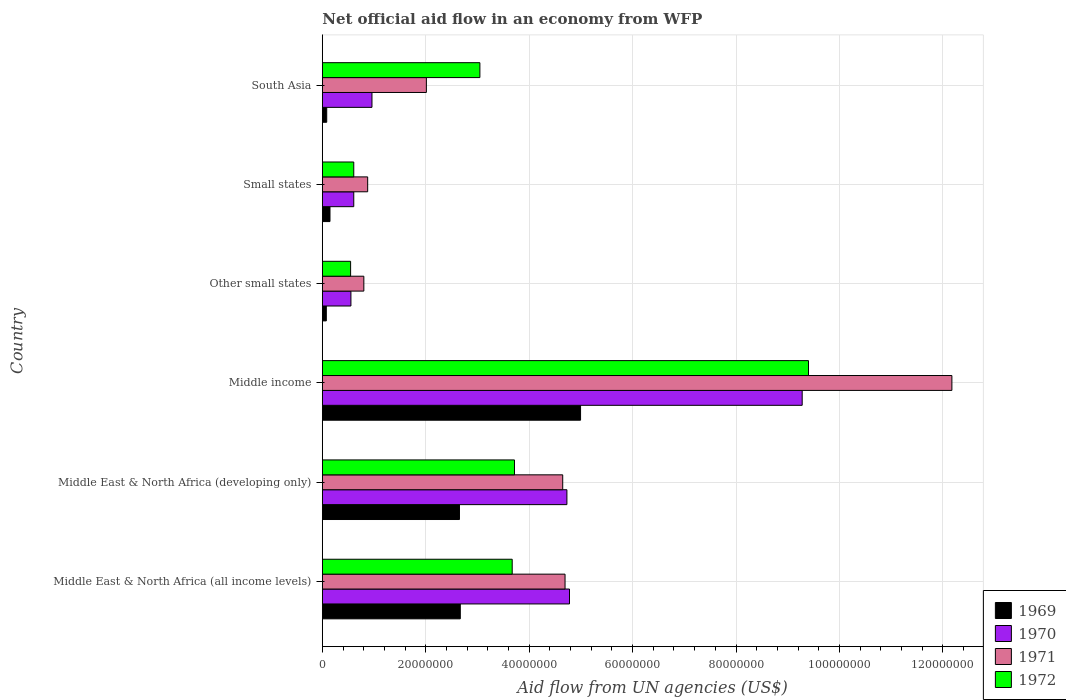How many different coloured bars are there?
Provide a short and direct response. 4. How many groups of bars are there?
Your response must be concise. 6. Are the number of bars per tick equal to the number of legend labels?
Offer a terse response. Yes. Are the number of bars on each tick of the Y-axis equal?
Offer a very short reply. Yes. How many bars are there on the 1st tick from the bottom?
Offer a very short reply. 4. What is the label of the 1st group of bars from the top?
Ensure brevity in your answer.  South Asia. In how many cases, is the number of bars for a given country not equal to the number of legend labels?
Your answer should be very brief. 0. What is the net official aid flow in 1969 in Other small states?
Your response must be concise. 7.70e+05. Across all countries, what is the maximum net official aid flow in 1969?
Make the answer very short. 4.99e+07. Across all countries, what is the minimum net official aid flow in 1971?
Your answer should be very brief. 8.03e+06. In which country was the net official aid flow in 1972 maximum?
Keep it short and to the point. Middle income. In which country was the net official aid flow in 1970 minimum?
Give a very brief answer. Other small states. What is the total net official aid flow in 1970 in the graph?
Provide a succinct answer. 2.09e+08. What is the difference between the net official aid flow in 1972 in Middle East & North Africa (all income levels) and that in Other small states?
Your answer should be compact. 3.12e+07. What is the difference between the net official aid flow in 1971 in Middle East & North Africa (all income levels) and the net official aid flow in 1969 in Small states?
Provide a succinct answer. 4.55e+07. What is the average net official aid flow in 1971 per country?
Provide a short and direct response. 4.20e+07. What is the difference between the net official aid flow in 1970 and net official aid flow in 1971 in Middle income?
Offer a terse response. -2.90e+07. What is the ratio of the net official aid flow in 1972 in Other small states to that in South Asia?
Provide a succinct answer. 0.18. Is the net official aid flow in 1969 in Middle East & North Africa (all income levels) less than that in Small states?
Give a very brief answer. No. What is the difference between the highest and the second highest net official aid flow in 1969?
Your answer should be very brief. 2.33e+07. What is the difference between the highest and the lowest net official aid flow in 1969?
Provide a succinct answer. 4.92e+07. In how many countries, is the net official aid flow in 1970 greater than the average net official aid flow in 1970 taken over all countries?
Provide a short and direct response. 3. What does the 1st bar from the bottom in Middle East & North Africa (all income levels) represents?
Provide a short and direct response. 1969. How many bars are there?
Make the answer very short. 24. Are all the bars in the graph horizontal?
Ensure brevity in your answer.  Yes. How many countries are there in the graph?
Offer a terse response. 6. What is the difference between two consecutive major ticks on the X-axis?
Offer a very short reply. 2.00e+07. Does the graph contain grids?
Make the answer very short. Yes. How are the legend labels stacked?
Your answer should be compact. Vertical. What is the title of the graph?
Provide a succinct answer. Net official aid flow in an economy from WFP. What is the label or title of the X-axis?
Provide a short and direct response. Aid flow from UN agencies (US$). What is the label or title of the Y-axis?
Offer a very short reply. Country. What is the Aid flow from UN agencies (US$) of 1969 in Middle East & North Africa (all income levels)?
Your answer should be very brief. 2.67e+07. What is the Aid flow from UN agencies (US$) of 1970 in Middle East & North Africa (all income levels)?
Ensure brevity in your answer.  4.78e+07. What is the Aid flow from UN agencies (US$) in 1971 in Middle East & North Africa (all income levels)?
Your answer should be compact. 4.69e+07. What is the Aid flow from UN agencies (US$) of 1972 in Middle East & North Africa (all income levels)?
Make the answer very short. 3.67e+07. What is the Aid flow from UN agencies (US$) of 1969 in Middle East & North Africa (developing only)?
Keep it short and to the point. 2.65e+07. What is the Aid flow from UN agencies (US$) in 1970 in Middle East & North Africa (developing only)?
Your response must be concise. 4.73e+07. What is the Aid flow from UN agencies (US$) of 1971 in Middle East & North Africa (developing only)?
Your answer should be compact. 4.65e+07. What is the Aid flow from UN agencies (US$) in 1972 in Middle East & North Africa (developing only)?
Make the answer very short. 3.72e+07. What is the Aid flow from UN agencies (US$) in 1969 in Middle income?
Keep it short and to the point. 4.99e+07. What is the Aid flow from UN agencies (US$) in 1970 in Middle income?
Your answer should be compact. 9.28e+07. What is the Aid flow from UN agencies (US$) in 1971 in Middle income?
Provide a short and direct response. 1.22e+08. What is the Aid flow from UN agencies (US$) of 1972 in Middle income?
Give a very brief answer. 9.40e+07. What is the Aid flow from UN agencies (US$) of 1969 in Other small states?
Keep it short and to the point. 7.70e+05. What is the Aid flow from UN agencies (US$) of 1970 in Other small states?
Provide a succinct answer. 5.53e+06. What is the Aid flow from UN agencies (US$) of 1971 in Other small states?
Ensure brevity in your answer.  8.03e+06. What is the Aid flow from UN agencies (US$) in 1972 in Other small states?
Provide a succinct answer. 5.47e+06. What is the Aid flow from UN agencies (US$) of 1969 in Small states?
Ensure brevity in your answer.  1.48e+06. What is the Aid flow from UN agencies (US$) in 1970 in Small states?
Provide a succinct answer. 6.08e+06. What is the Aid flow from UN agencies (US$) in 1971 in Small states?
Offer a terse response. 8.77e+06. What is the Aid flow from UN agencies (US$) of 1972 in Small states?
Your answer should be very brief. 6.08e+06. What is the Aid flow from UN agencies (US$) of 1969 in South Asia?
Ensure brevity in your answer.  8.50e+05. What is the Aid flow from UN agencies (US$) in 1970 in South Asia?
Give a very brief answer. 9.60e+06. What is the Aid flow from UN agencies (US$) of 1971 in South Asia?
Provide a short and direct response. 2.01e+07. What is the Aid flow from UN agencies (US$) in 1972 in South Asia?
Keep it short and to the point. 3.05e+07. Across all countries, what is the maximum Aid flow from UN agencies (US$) in 1969?
Provide a short and direct response. 4.99e+07. Across all countries, what is the maximum Aid flow from UN agencies (US$) in 1970?
Your answer should be very brief. 9.28e+07. Across all countries, what is the maximum Aid flow from UN agencies (US$) in 1971?
Your answer should be compact. 1.22e+08. Across all countries, what is the maximum Aid flow from UN agencies (US$) of 1972?
Provide a succinct answer. 9.40e+07. Across all countries, what is the minimum Aid flow from UN agencies (US$) in 1969?
Your answer should be compact. 7.70e+05. Across all countries, what is the minimum Aid flow from UN agencies (US$) in 1970?
Your response must be concise. 5.53e+06. Across all countries, what is the minimum Aid flow from UN agencies (US$) of 1971?
Offer a very short reply. 8.03e+06. Across all countries, what is the minimum Aid flow from UN agencies (US$) of 1972?
Your answer should be compact. 5.47e+06. What is the total Aid flow from UN agencies (US$) in 1969 in the graph?
Keep it short and to the point. 1.06e+08. What is the total Aid flow from UN agencies (US$) of 1970 in the graph?
Make the answer very short. 2.09e+08. What is the total Aid flow from UN agencies (US$) of 1971 in the graph?
Keep it short and to the point. 2.52e+08. What is the total Aid flow from UN agencies (US$) in 1972 in the graph?
Your answer should be compact. 2.10e+08. What is the difference between the Aid flow from UN agencies (US$) in 1969 in Middle East & North Africa (all income levels) and that in Middle East & North Africa (developing only)?
Ensure brevity in your answer.  1.60e+05. What is the difference between the Aid flow from UN agencies (US$) in 1972 in Middle East & North Africa (all income levels) and that in Middle East & North Africa (developing only)?
Make the answer very short. -4.40e+05. What is the difference between the Aid flow from UN agencies (US$) of 1969 in Middle East & North Africa (all income levels) and that in Middle income?
Your response must be concise. -2.33e+07. What is the difference between the Aid flow from UN agencies (US$) of 1970 in Middle East & North Africa (all income levels) and that in Middle income?
Provide a short and direct response. -4.50e+07. What is the difference between the Aid flow from UN agencies (US$) of 1971 in Middle East & North Africa (all income levels) and that in Middle income?
Give a very brief answer. -7.48e+07. What is the difference between the Aid flow from UN agencies (US$) of 1972 in Middle East & North Africa (all income levels) and that in Middle income?
Make the answer very short. -5.73e+07. What is the difference between the Aid flow from UN agencies (US$) of 1969 in Middle East & North Africa (all income levels) and that in Other small states?
Provide a succinct answer. 2.59e+07. What is the difference between the Aid flow from UN agencies (US$) of 1970 in Middle East & North Africa (all income levels) and that in Other small states?
Keep it short and to the point. 4.23e+07. What is the difference between the Aid flow from UN agencies (US$) in 1971 in Middle East & North Africa (all income levels) and that in Other small states?
Provide a succinct answer. 3.89e+07. What is the difference between the Aid flow from UN agencies (US$) of 1972 in Middle East & North Africa (all income levels) and that in Other small states?
Offer a very short reply. 3.12e+07. What is the difference between the Aid flow from UN agencies (US$) in 1969 in Middle East & North Africa (all income levels) and that in Small states?
Keep it short and to the point. 2.52e+07. What is the difference between the Aid flow from UN agencies (US$) in 1970 in Middle East & North Africa (all income levels) and that in Small states?
Make the answer very short. 4.17e+07. What is the difference between the Aid flow from UN agencies (US$) in 1971 in Middle East & North Africa (all income levels) and that in Small states?
Your response must be concise. 3.82e+07. What is the difference between the Aid flow from UN agencies (US$) of 1972 in Middle East & North Africa (all income levels) and that in Small states?
Your response must be concise. 3.06e+07. What is the difference between the Aid flow from UN agencies (US$) of 1969 in Middle East & North Africa (all income levels) and that in South Asia?
Give a very brief answer. 2.58e+07. What is the difference between the Aid flow from UN agencies (US$) in 1970 in Middle East & North Africa (all income levels) and that in South Asia?
Make the answer very short. 3.82e+07. What is the difference between the Aid flow from UN agencies (US$) of 1971 in Middle East & North Africa (all income levels) and that in South Asia?
Your answer should be very brief. 2.68e+07. What is the difference between the Aid flow from UN agencies (US$) of 1972 in Middle East & North Africa (all income levels) and that in South Asia?
Ensure brevity in your answer.  6.25e+06. What is the difference between the Aid flow from UN agencies (US$) of 1969 in Middle East & North Africa (developing only) and that in Middle income?
Your answer should be very brief. -2.34e+07. What is the difference between the Aid flow from UN agencies (US$) in 1970 in Middle East & North Africa (developing only) and that in Middle income?
Keep it short and to the point. -4.55e+07. What is the difference between the Aid flow from UN agencies (US$) of 1971 in Middle East & North Africa (developing only) and that in Middle income?
Provide a succinct answer. -7.53e+07. What is the difference between the Aid flow from UN agencies (US$) in 1972 in Middle East & North Africa (developing only) and that in Middle income?
Ensure brevity in your answer.  -5.69e+07. What is the difference between the Aid flow from UN agencies (US$) in 1969 in Middle East & North Africa (developing only) and that in Other small states?
Your answer should be compact. 2.58e+07. What is the difference between the Aid flow from UN agencies (US$) in 1970 in Middle East & North Africa (developing only) and that in Other small states?
Ensure brevity in your answer.  4.18e+07. What is the difference between the Aid flow from UN agencies (US$) of 1971 in Middle East & North Africa (developing only) and that in Other small states?
Your response must be concise. 3.85e+07. What is the difference between the Aid flow from UN agencies (US$) in 1972 in Middle East & North Africa (developing only) and that in Other small states?
Give a very brief answer. 3.17e+07. What is the difference between the Aid flow from UN agencies (US$) of 1969 in Middle East & North Africa (developing only) and that in Small states?
Keep it short and to the point. 2.50e+07. What is the difference between the Aid flow from UN agencies (US$) of 1970 in Middle East & North Africa (developing only) and that in Small states?
Provide a short and direct response. 4.12e+07. What is the difference between the Aid flow from UN agencies (US$) in 1971 in Middle East & North Africa (developing only) and that in Small states?
Give a very brief answer. 3.77e+07. What is the difference between the Aid flow from UN agencies (US$) of 1972 in Middle East & North Africa (developing only) and that in Small states?
Provide a succinct answer. 3.11e+07. What is the difference between the Aid flow from UN agencies (US$) in 1969 in Middle East & North Africa (developing only) and that in South Asia?
Your answer should be compact. 2.57e+07. What is the difference between the Aid flow from UN agencies (US$) in 1970 in Middle East & North Africa (developing only) and that in South Asia?
Provide a succinct answer. 3.77e+07. What is the difference between the Aid flow from UN agencies (US$) of 1971 in Middle East & North Africa (developing only) and that in South Asia?
Provide a succinct answer. 2.64e+07. What is the difference between the Aid flow from UN agencies (US$) of 1972 in Middle East & North Africa (developing only) and that in South Asia?
Your response must be concise. 6.69e+06. What is the difference between the Aid flow from UN agencies (US$) of 1969 in Middle income and that in Other small states?
Your response must be concise. 4.92e+07. What is the difference between the Aid flow from UN agencies (US$) of 1970 in Middle income and that in Other small states?
Ensure brevity in your answer.  8.73e+07. What is the difference between the Aid flow from UN agencies (US$) in 1971 in Middle income and that in Other small states?
Provide a succinct answer. 1.14e+08. What is the difference between the Aid flow from UN agencies (US$) in 1972 in Middle income and that in Other small states?
Your answer should be very brief. 8.86e+07. What is the difference between the Aid flow from UN agencies (US$) of 1969 in Middle income and that in Small states?
Your answer should be compact. 4.85e+07. What is the difference between the Aid flow from UN agencies (US$) of 1970 in Middle income and that in Small states?
Offer a very short reply. 8.67e+07. What is the difference between the Aid flow from UN agencies (US$) in 1971 in Middle income and that in Small states?
Make the answer very short. 1.13e+08. What is the difference between the Aid flow from UN agencies (US$) of 1972 in Middle income and that in Small states?
Offer a very short reply. 8.79e+07. What is the difference between the Aid flow from UN agencies (US$) of 1969 in Middle income and that in South Asia?
Offer a very short reply. 4.91e+07. What is the difference between the Aid flow from UN agencies (US$) of 1970 in Middle income and that in South Asia?
Ensure brevity in your answer.  8.32e+07. What is the difference between the Aid flow from UN agencies (US$) in 1971 in Middle income and that in South Asia?
Keep it short and to the point. 1.02e+08. What is the difference between the Aid flow from UN agencies (US$) in 1972 in Middle income and that in South Asia?
Give a very brief answer. 6.36e+07. What is the difference between the Aid flow from UN agencies (US$) in 1969 in Other small states and that in Small states?
Ensure brevity in your answer.  -7.10e+05. What is the difference between the Aid flow from UN agencies (US$) in 1970 in Other small states and that in Small states?
Your answer should be very brief. -5.50e+05. What is the difference between the Aid flow from UN agencies (US$) of 1971 in Other small states and that in Small states?
Keep it short and to the point. -7.40e+05. What is the difference between the Aid flow from UN agencies (US$) in 1972 in Other small states and that in Small states?
Offer a very short reply. -6.10e+05. What is the difference between the Aid flow from UN agencies (US$) of 1969 in Other small states and that in South Asia?
Offer a very short reply. -8.00e+04. What is the difference between the Aid flow from UN agencies (US$) of 1970 in Other small states and that in South Asia?
Provide a short and direct response. -4.07e+06. What is the difference between the Aid flow from UN agencies (US$) of 1971 in Other small states and that in South Asia?
Make the answer very short. -1.21e+07. What is the difference between the Aid flow from UN agencies (US$) in 1972 in Other small states and that in South Asia?
Provide a succinct answer. -2.50e+07. What is the difference between the Aid flow from UN agencies (US$) of 1969 in Small states and that in South Asia?
Offer a terse response. 6.30e+05. What is the difference between the Aid flow from UN agencies (US$) in 1970 in Small states and that in South Asia?
Provide a short and direct response. -3.52e+06. What is the difference between the Aid flow from UN agencies (US$) in 1971 in Small states and that in South Asia?
Offer a very short reply. -1.14e+07. What is the difference between the Aid flow from UN agencies (US$) of 1972 in Small states and that in South Asia?
Ensure brevity in your answer.  -2.44e+07. What is the difference between the Aid flow from UN agencies (US$) of 1969 in Middle East & North Africa (all income levels) and the Aid flow from UN agencies (US$) of 1970 in Middle East & North Africa (developing only)?
Offer a terse response. -2.06e+07. What is the difference between the Aid flow from UN agencies (US$) in 1969 in Middle East & North Africa (all income levels) and the Aid flow from UN agencies (US$) in 1971 in Middle East & North Africa (developing only)?
Ensure brevity in your answer.  -1.98e+07. What is the difference between the Aid flow from UN agencies (US$) in 1969 in Middle East & North Africa (all income levels) and the Aid flow from UN agencies (US$) in 1972 in Middle East & North Africa (developing only)?
Keep it short and to the point. -1.05e+07. What is the difference between the Aid flow from UN agencies (US$) in 1970 in Middle East & North Africa (all income levels) and the Aid flow from UN agencies (US$) in 1971 in Middle East & North Africa (developing only)?
Keep it short and to the point. 1.31e+06. What is the difference between the Aid flow from UN agencies (US$) of 1970 in Middle East & North Africa (all income levels) and the Aid flow from UN agencies (US$) of 1972 in Middle East & North Africa (developing only)?
Provide a succinct answer. 1.06e+07. What is the difference between the Aid flow from UN agencies (US$) of 1971 in Middle East & North Africa (all income levels) and the Aid flow from UN agencies (US$) of 1972 in Middle East & North Africa (developing only)?
Make the answer very short. 9.78e+06. What is the difference between the Aid flow from UN agencies (US$) in 1969 in Middle East & North Africa (all income levels) and the Aid flow from UN agencies (US$) in 1970 in Middle income?
Your answer should be very brief. -6.61e+07. What is the difference between the Aid flow from UN agencies (US$) in 1969 in Middle East & North Africa (all income levels) and the Aid flow from UN agencies (US$) in 1971 in Middle income?
Offer a very short reply. -9.51e+07. What is the difference between the Aid flow from UN agencies (US$) of 1969 in Middle East & North Africa (all income levels) and the Aid flow from UN agencies (US$) of 1972 in Middle income?
Provide a succinct answer. -6.73e+07. What is the difference between the Aid flow from UN agencies (US$) of 1970 in Middle East & North Africa (all income levels) and the Aid flow from UN agencies (US$) of 1971 in Middle income?
Your response must be concise. -7.40e+07. What is the difference between the Aid flow from UN agencies (US$) of 1970 in Middle East & North Africa (all income levels) and the Aid flow from UN agencies (US$) of 1972 in Middle income?
Provide a succinct answer. -4.62e+07. What is the difference between the Aid flow from UN agencies (US$) of 1971 in Middle East & North Africa (all income levels) and the Aid flow from UN agencies (US$) of 1972 in Middle income?
Make the answer very short. -4.71e+07. What is the difference between the Aid flow from UN agencies (US$) in 1969 in Middle East & North Africa (all income levels) and the Aid flow from UN agencies (US$) in 1970 in Other small states?
Your answer should be compact. 2.12e+07. What is the difference between the Aid flow from UN agencies (US$) of 1969 in Middle East & North Africa (all income levels) and the Aid flow from UN agencies (US$) of 1971 in Other small states?
Provide a succinct answer. 1.86e+07. What is the difference between the Aid flow from UN agencies (US$) in 1969 in Middle East & North Africa (all income levels) and the Aid flow from UN agencies (US$) in 1972 in Other small states?
Give a very brief answer. 2.12e+07. What is the difference between the Aid flow from UN agencies (US$) in 1970 in Middle East & North Africa (all income levels) and the Aid flow from UN agencies (US$) in 1971 in Other small states?
Provide a short and direct response. 3.98e+07. What is the difference between the Aid flow from UN agencies (US$) in 1970 in Middle East & North Africa (all income levels) and the Aid flow from UN agencies (US$) in 1972 in Other small states?
Offer a very short reply. 4.23e+07. What is the difference between the Aid flow from UN agencies (US$) in 1971 in Middle East & North Africa (all income levels) and the Aid flow from UN agencies (US$) in 1972 in Other small states?
Offer a very short reply. 4.15e+07. What is the difference between the Aid flow from UN agencies (US$) of 1969 in Middle East & North Africa (all income levels) and the Aid flow from UN agencies (US$) of 1970 in Small states?
Keep it short and to the point. 2.06e+07. What is the difference between the Aid flow from UN agencies (US$) in 1969 in Middle East & North Africa (all income levels) and the Aid flow from UN agencies (US$) in 1971 in Small states?
Your answer should be very brief. 1.79e+07. What is the difference between the Aid flow from UN agencies (US$) of 1969 in Middle East & North Africa (all income levels) and the Aid flow from UN agencies (US$) of 1972 in Small states?
Your answer should be very brief. 2.06e+07. What is the difference between the Aid flow from UN agencies (US$) of 1970 in Middle East & North Africa (all income levels) and the Aid flow from UN agencies (US$) of 1971 in Small states?
Provide a succinct answer. 3.90e+07. What is the difference between the Aid flow from UN agencies (US$) in 1970 in Middle East & North Africa (all income levels) and the Aid flow from UN agencies (US$) in 1972 in Small states?
Keep it short and to the point. 4.17e+07. What is the difference between the Aid flow from UN agencies (US$) of 1971 in Middle East & North Africa (all income levels) and the Aid flow from UN agencies (US$) of 1972 in Small states?
Make the answer very short. 4.09e+07. What is the difference between the Aid flow from UN agencies (US$) of 1969 in Middle East & North Africa (all income levels) and the Aid flow from UN agencies (US$) of 1970 in South Asia?
Offer a terse response. 1.71e+07. What is the difference between the Aid flow from UN agencies (US$) in 1969 in Middle East & North Africa (all income levels) and the Aid flow from UN agencies (US$) in 1971 in South Asia?
Your answer should be very brief. 6.56e+06. What is the difference between the Aid flow from UN agencies (US$) in 1969 in Middle East & North Africa (all income levels) and the Aid flow from UN agencies (US$) in 1972 in South Asia?
Give a very brief answer. -3.79e+06. What is the difference between the Aid flow from UN agencies (US$) of 1970 in Middle East & North Africa (all income levels) and the Aid flow from UN agencies (US$) of 1971 in South Asia?
Your response must be concise. 2.77e+07. What is the difference between the Aid flow from UN agencies (US$) in 1970 in Middle East & North Africa (all income levels) and the Aid flow from UN agencies (US$) in 1972 in South Asia?
Give a very brief answer. 1.73e+07. What is the difference between the Aid flow from UN agencies (US$) of 1971 in Middle East & North Africa (all income levels) and the Aid flow from UN agencies (US$) of 1972 in South Asia?
Provide a succinct answer. 1.65e+07. What is the difference between the Aid flow from UN agencies (US$) in 1969 in Middle East & North Africa (developing only) and the Aid flow from UN agencies (US$) in 1970 in Middle income?
Provide a short and direct response. -6.63e+07. What is the difference between the Aid flow from UN agencies (US$) of 1969 in Middle East & North Africa (developing only) and the Aid flow from UN agencies (US$) of 1971 in Middle income?
Provide a succinct answer. -9.52e+07. What is the difference between the Aid flow from UN agencies (US$) of 1969 in Middle East & North Africa (developing only) and the Aid flow from UN agencies (US$) of 1972 in Middle income?
Offer a very short reply. -6.75e+07. What is the difference between the Aid flow from UN agencies (US$) of 1970 in Middle East & North Africa (developing only) and the Aid flow from UN agencies (US$) of 1971 in Middle income?
Keep it short and to the point. -7.44e+07. What is the difference between the Aid flow from UN agencies (US$) of 1970 in Middle East & North Africa (developing only) and the Aid flow from UN agencies (US$) of 1972 in Middle income?
Your answer should be compact. -4.67e+07. What is the difference between the Aid flow from UN agencies (US$) in 1971 in Middle East & North Africa (developing only) and the Aid flow from UN agencies (US$) in 1972 in Middle income?
Your answer should be very brief. -4.75e+07. What is the difference between the Aid flow from UN agencies (US$) of 1969 in Middle East & North Africa (developing only) and the Aid flow from UN agencies (US$) of 1970 in Other small states?
Give a very brief answer. 2.10e+07. What is the difference between the Aid flow from UN agencies (US$) in 1969 in Middle East & North Africa (developing only) and the Aid flow from UN agencies (US$) in 1971 in Other small states?
Your response must be concise. 1.85e+07. What is the difference between the Aid flow from UN agencies (US$) of 1969 in Middle East & North Africa (developing only) and the Aid flow from UN agencies (US$) of 1972 in Other small states?
Your answer should be compact. 2.10e+07. What is the difference between the Aid flow from UN agencies (US$) of 1970 in Middle East & North Africa (developing only) and the Aid flow from UN agencies (US$) of 1971 in Other small states?
Ensure brevity in your answer.  3.93e+07. What is the difference between the Aid flow from UN agencies (US$) in 1970 in Middle East & North Africa (developing only) and the Aid flow from UN agencies (US$) in 1972 in Other small states?
Provide a short and direct response. 4.18e+07. What is the difference between the Aid flow from UN agencies (US$) of 1971 in Middle East & North Africa (developing only) and the Aid flow from UN agencies (US$) of 1972 in Other small states?
Make the answer very short. 4.10e+07. What is the difference between the Aid flow from UN agencies (US$) of 1969 in Middle East & North Africa (developing only) and the Aid flow from UN agencies (US$) of 1970 in Small states?
Provide a succinct answer. 2.04e+07. What is the difference between the Aid flow from UN agencies (US$) of 1969 in Middle East & North Africa (developing only) and the Aid flow from UN agencies (US$) of 1971 in Small states?
Your response must be concise. 1.78e+07. What is the difference between the Aid flow from UN agencies (US$) in 1969 in Middle East & North Africa (developing only) and the Aid flow from UN agencies (US$) in 1972 in Small states?
Ensure brevity in your answer.  2.04e+07. What is the difference between the Aid flow from UN agencies (US$) of 1970 in Middle East & North Africa (developing only) and the Aid flow from UN agencies (US$) of 1971 in Small states?
Keep it short and to the point. 3.85e+07. What is the difference between the Aid flow from UN agencies (US$) in 1970 in Middle East & North Africa (developing only) and the Aid flow from UN agencies (US$) in 1972 in Small states?
Make the answer very short. 4.12e+07. What is the difference between the Aid flow from UN agencies (US$) of 1971 in Middle East & North Africa (developing only) and the Aid flow from UN agencies (US$) of 1972 in Small states?
Offer a terse response. 4.04e+07. What is the difference between the Aid flow from UN agencies (US$) in 1969 in Middle East & North Africa (developing only) and the Aid flow from UN agencies (US$) in 1970 in South Asia?
Provide a succinct answer. 1.69e+07. What is the difference between the Aid flow from UN agencies (US$) in 1969 in Middle East & North Africa (developing only) and the Aid flow from UN agencies (US$) in 1971 in South Asia?
Ensure brevity in your answer.  6.40e+06. What is the difference between the Aid flow from UN agencies (US$) of 1969 in Middle East & North Africa (developing only) and the Aid flow from UN agencies (US$) of 1972 in South Asia?
Make the answer very short. -3.95e+06. What is the difference between the Aid flow from UN agencies (US$) of 1970 in Middle East & North Africa (developing only) and the Aid flow from UN agencies (US$) of 1971 in South Asia?
Make the answer very short. 2.72e+07. What is the difference between the Aid flow from UN agencies (US$) of 1970 in Middle East & North Africa (developing only) and the Aid flow from UN agencies (US$) of 1972 in South Asia?
Give a very brief answer. 1.68e+07. What is the difference between the Aid flow from UN agencies (US$) of 1971 in Middle East & North Africa (developing only) and the Aid flow from UN agencies (US$) of 1972 in South Asia?
Your response must be concise. 1.60e+07. What is the difference between the Aid flow from UN agencies (US$) in 1969 in Middle income and the Aid flow from UN agencies (US$) in 1970 in Other small states?
Offer a very short reply. 4.44e+07. What is the difference between the Aid flow from UN agencies (US$) of 1969 in Middle income and the Aid flow from UN agencies (US$) of 1971 in Other small states?
Provide a short and direct response. 4.19e+07. What is the difference between the Aid flow from UN agencies (US$) of 1969 in Middle income and the Aid flow from UN agencies (US$) of 1972 in Other small states?
Provide a succinct answer. 4.45e+07. What is the difference between the Aid flow from UN agencies (US$) of 1970 in Middle income and the Aid flow from UN agencies (US$) of 1971 in Other small states?
Your answer should be compact. 8.48e+07. What is the difference between the Aid flow from UN agencies (US$) of 1970 in Middle income and the Aid flow from UN agencies (US$) of 1972 in Other small states?
Keep it short and to the point. 8.73e+07. What is the difference between the Aid flow from UN agencies (US$) of 1971 in Middle income and the Aid flow from UN agencies (US$) of 1972 in Other small states?
Provide a short and direct response. 1.16e+08. What is the difference between the Aid flow from UN agencies (US$) in 1969 in Middle income and the Aid flow from UN agencies (US$) in 1970 in Small states?
Your response must be concise. 4.39e+07. What is the difference between the Aid flow from UN agencies (US$) in 1969 in Middle income and the Aid flow from UN agencies (US$) in 1971 in Small states?
Give a very brief answer. 4.12e+07. What is the difference between the Aid flow from UN agencies (US$) of 1969 in Middle income and the Aid flow from UN agencies (US$) of 1972 in Small states?
Provide a succinct answer. 4.39e+07. What is the difference between the Aid flow from UN agencies (US$) of 1970 in Middle income and the Aid flow from UN agencies (US$) of 1971 in Small states?
Give a very brief answer. 8.40e+07. What is the difference between the Aid flow from UN agencies (US$) in 1970 in Middle income and the Aid flow from UN agencies (US$) in 1972 in Small states?
Provide a succinct answer. 8.67e+07. What is the difference between the Aid flow from UN agencies (US$) of 1971 in Middle income and the Aid flow from UN agencies (US$) of 1972 in Small states?
Your response must be concise. 1.16e+08. What is the difference between the Aid flow from UN agencies (US$) of 1969 in Middle income and the Aid flow from UN agencies (US$) of 1970 in South Asia?
Ensure brevity in your answer.  4.03e+07. What is the difference between the Aid flow from UN agencies (US$) in 1969 in Middle income and the Aid flow from UN agencies (US$) in 1971 in South Asia?
Your answer should be compact. 2.98e+07. What is the difference between the Aid flow from UN agencies (US$) of 1969 in Middle income and the Aid flow from UN agencies (US$) of 1972 in South Asia?
Offer a terse response. 1.95e+07. What is the difference between the Aid flow from UN agencies (US$) of 1970 in Middle income and the Aid flow from UN agencies (US$) of 1971 in South Asia?
Your answer should be very brief. 7.27e+07. What is the difference between the Aid flow from UN agencies (US$) in 1970 in Middle income and the Aid flow from UN agencies (US$) in 1972 in South Asia?
Ensure brevity in your answer.  6.23e+07. What is the difference between the Aid flow from UN agencies (US$) of 1971 in Middle income and the Aid flow from UN agencies (US$) of 1972 in South Asia?
Your answer should be compact. 9.13e+07. What is the difference between the Aid flow from UN agencies (US$) of 1969 in Other small states and the Aid flow from UN agencies (US$) of 1970 in Small states?
Give a very brief answer. -5.31e+06. What is the difference between the Aid flow from UN agencies (US$) of 1969 in Other small states and the Aid flow from UN agencies (US$) of 1971 in Small states?
Offer a terse response. -8.00e+06. What is the difference between the Aid flow from UN agencies (US$) in 1969 in Other small states and the Aid flow from UN agencies (US$) in 1972 in Small states?
Your response must be concise. -5.31e+06. What is the difference between the Aid flow from UN agencies (US$) in 1970 in Other small states and the Aid flow from UN agencies (US$) in 1971 in Small states?
Keep it short and to the point. -3.24e+06. What is the difference between the Aid flow from UN agencies (US$) of 1970 in Other small states and the Aid flow from UN agencies (US$) of 1972 in Small states?
Give a very brief answer. -5.50e+05. What is the difference between the Aid flow from UN agencies (US$) in 1971 in Other small states and the Aid flow from UN agencies (US$) in 1972 in Small states?
Your answer should be compact. 1.95e+06. What is the difference between the Aid flow from UN agencies (US$) in 1969 in Other small states and the Aid flow from UN agencies (US$) in 1970 in South Asia?
Your response must be concise. -8.83e+06. What is the difference between the Aid flow from UN agencies (US$) of 1969 in Other small states and the Aid flow from UN agencies (US$) of 1971 in South Asia?
Ensure brevity in your answer.  -1.94e+07. What is the difference between the Aid flow from UN agencies (US$) in 1969 in Other small states and the Aid flow from UN agencies (US$) in 1972 in South Asia?
Your answer should be very brief. -2.97e+07. What is the difference between the Aid flow from UN agencies (US$) in 1970 in Other small states and the Aid flow from UN agencies (US$) in 1971 in South Asia?
Your answer should be compact. -1.46e+07. What is the difference between the Aid flow from UN agencies (US$) in 1970 in Other small states and the Aid flow from UN agencies (US$) in 1972 in South Asia?
Your answer should be very brief. -2.49e+07. What is the difference between the Aid flow from UN agencies (US$) in 1971 in Other small states and the Aid flow from UN agencies (US$) in 1972 in South Asia?
Your answer should be very brief. -2.24e+07. What is the difference between the Aid flow from UN agencies (US$) of 1969 in Small states and the Aid flow from UN agencies (US$) of 1970 in South Asia?
Provide a succinct answer. -8.12e+06. What is the difference between the Aid flow from UN agencies (US$) of 1969 in Small states and the Aid flow from UN agencies (US$) of 1971 in South Asia?
Your answer should be very brief. -1.86e+07. What is the difference between the Aid flow from UN agencies (US$) in 1969 in Small states and the Aid flow from UN agencies (US$) in 1972 in South Asia?
Your response must be concise. -2.90e+07. What is the difference between the Aid flow from UN agencies (US$) in 1970 in Small states and the Aid flow from UN agencies (US$) in 1971 in South Asia?
Make the answer very short. -1.40e+07. What is the difference between the Aid flow from UN agencies (US$) in 1970 in Small states and the Aid flow from UN agencies (US$) in 1972 in South Asia?
Your response must be concise. -2.44e+07. What is the difference between the Aid flow from UN agencies (US$) of 1971 in Small states and the Aid flow from UN agencies (US$) of 1972 in South Asia?
Offer a very short reply. -2.17e+07. What is the average Aid flow from UN agencies (US$) of 1969 per country?
Provide a succinct answer. 1.77e+07. What is the average Aid flow from UN agencies (US$) in 1970 per country?
Your answer should be compact. 3.49e+07. What is the average Aid flow from UN agencies (US$) in 1971 per country?
Provide a short and direct response. 4.20e+07. What is the average Aid flow from UN agencies (US$) of 1972 per country?
Make the answer very short. 3.50e+07. What is the difference between the Aid flow from UN agencies (US$) in 1969 and Aid flow from UN agencies (US$) in 1970 in Middle East & North Africa (all income levels)?
Provide a succinct answer. -2.11e+07. What is the difference between the Aid flow from UN agencies (US$) in 1969 and Aid flow from UN agencies (US$) in 1971 in Middle East & North Africa (all income levels)?
Keep it short and to the point. -2.03e+07. What is the difference between the Aid flow from UN agencies (US$) of 1969 and Aid flow from UN agencies (US$) of 1972 in Middle East & North Africa (all income levels)?
Provide a short and direct response. -1.00e+07. What is the difference between the Aid flow from UN agencies (US$) in 1970 and Aid flow from UN agencies (US$) in 1971 in Middle East & North Africa (all income levels)?
Offer a very short reply. 8.60e+05. What is the difference between the Aid flow from UN agencies (US$) in 1970 and Aid flow from UN agencies (US$) in 1972 in Middle East & North Africa (all income levels)?
Your answer should be very brief. 1.11e+07. What is the difference between the Aid flow from UN agencies (US$) in 1971 and Aid flow from UN agencies (US$) in 1972 in Middle East & North Africa (all income levels)?
Offer a terse response. 1.02e+07. What is the difference between the Aid flow from UN agencies (US$) in 1969 and Aid flow from UN agencies (US$) in 1970 in Middle East & North Africa (developing only)?
Your response must be concise. -2.08e+07. What is the difference between the Aid flow from UN agencies (US$) of 1969 and Aid flow from UN agencies (US$) of 1971 in Middle East & North Africa (developing only)?
Your response must be concise. -2.00e+07. What is the difference between the Aid flow from UN agencies (US$) in 1969 and Aid flow from UN agencies (US$) in 1972 in Middle East & North Africa (developing only)?
Make the answer very short. -1.06e+07. What is the difference between the Aid flow from UN agencies (US$) of 1970 and Aid flow from UN agencies (US$) of 1971 in Middle East & North Africa (developing only)?
Keep it short and to the point. 8.10e+05. What is the difference between the Aid flow from UN agencies (US$) of 1970 and Aid flow from UN agencies (US$) of 1972 in Middle East & North Africa (developing only)?
Offer a terse response. 1.01e+07. What is the difference between the Aid flow from UN agencies (US$) of 1971 and Aid flow from UN agencies (US$) of 1972 in Middle East & North Africa (developing only)?
Make the answer very short. 9.33e+06. What is the difference between the Aid flow from UN agencies (US$) of 1969 and Aid flow from UN agencies (US$) of 1970 in Middle income?
Offer a very short reply. -4.29e+07. What is the difference between the Aid flow from UN agencies (US$) in 1969 and Aid flow from UN agencies (US$) in 1971 in Middle income?
Your answer should be compact. -7.18e+07. What is the difference between the Aid flow from UN agencies (US$) in 1969 and Aid flow from UN agencies (US$) in 1972 in Middle income?
Your response must be concise. -4.41e+07. What is the difference between the Aid flow from UN agencies (US$) of 1970 and Aid flow from UN agencies (US$) of 1971 in Middle income?
Keep it short and to the point. -2.90e+07. What is the difference between the Aid flow from UN agencies (US$) of 1970 and Aid flow from UN agencies (US$) of 1972 in Middle income?
Make the answer very short. -1.22e+06. What is the difference between the Aid flow from UN agencies (US$) in 1971 and Aid flow from UN agencies (US$) in 1972 in Middle income?
Ensure brevity in your answer.  2.77e+07. What is the difference between the Aid flow from UN agencies (US$) of 1969 and Aid flow from UN agencies (US$) of 1970 in Other small states?
Ensure brevity in your answer.  -4.76e+06. What is the difference between the Aid flow from UN agencies (US$) in 1969 and Aid flow from UN agencies (US$) in 1971 in Other small states?
Make the answer very short. -7.26e+06. What is the difference between the Aid flow from UN agencies (US$) of 1969 and Aid flow from UN agencies (US$) of 1972 in Other small states?
Your answer should be compact. -4.70e+06. What is the difference between the Aid flow from UN agencies (US$) of 1970 and Aid flow from UN agencies (US$) of 1971 in Other small states?
Your answer should be compact. -2.50e+06. What is the difference between the Aid flow from UN agencies (US$) of 1971 and Aid flow from UN agencies (US$) of 1972 in Other small states?
Make the answer very short. 2.56e+06. What is the difference between the Aid flow from UN agencies (US$) of 1969 and Aid flow from UN agencies (US$) of 1970 in Small states?
Keep it short and to the point. -4.60e+06. What is the difference between the Aid flow from UN agencies (US$) of 1969 and Aid flow from UN agencies (US$) of 1971 in Small states?
Keep it short and to the point. -7.29e+06. What is the difference between the Aid flow from UN agencies (US$) in 1969 and Aid flow from UN agencies (US$) in 1972 in Small states?
Your response must be concise. -4.60e+06. What is the difference between the Aid flow from UN agencies (US$) in 1970 and Aid flow from UN agencies (US$) in 1971 in Small states?
Offer a terse response. -2.69e+06. What is the difference between the Aid flow from UN agencies (US$) of 1971 and Aid flow from UN agencies (US$) of 1972 in Small states?
Keep it short and to the point. 2.69e+06. What is the difference between the Aid flow from UN agencies (US$) of 1969 and Aid flow from UN agencies (US$) of 1970 in South Asia?
Provide a succinct answer. -8.75e+06. What is the difference between the Aid flow from UN agencies (US$) of 1969 and Aid flow from UN agencies (US$) of 1971 in South Asia?
Offer a terse response. -1.93e+07. What is the difference between the Aid flow from UN agencies (US$) in 1969 and Aid flow from UN agencies (US$) in 1972 in South Asia?
Give a very brief answer. -2.96e+07. What is the difference between the Aid flow from UN agencies (US$) of 1970 and Aid flow from UN agencies (US$) of 1971 in South Asia?
Give a very brief answer. -1.05e+07. What is the difference between the Aid flow from UN agencies (US$) in 1970 and Aid flow from UN agencies (US$) in 1972 in South Asia?
Give a very brief answer. -2.09e+07. What is the difference between the Aid flow from UN agencies (US$) in 1971 and Aid flow from UN agencies (US$) in 1972 in South Asia?
Offer a terse response. -1.04e+07. What is the ratio of the Aid flow from UN agencies (US$) of 1969 in Middle East & North Africa (all income levels) to that in Middle East & North Africa (developing only)?
Provide a succinct answer. 1.01. What is the ratio of the Aid flow from UN agencies (US$) of 1970 in Middle East & North Africa (all income levels) to that in Middle East & North Africa (developing only)?
Make the answer very short. 1.01. What is the ratio of the Aid flow from UN agencies (US$) in 1971 in Middle East & North Africa (all income levels) to that in Middle East & North Africa (developing only)?
Your answer should be very brief. 1.01. What is the ratio of the Aid flow from UN agencies (US$) of 1972 in Middle East & North Africa (all income levels) to that in Middle East & North Africa (developing only)?
Keep it short and to the point. 0.99. What is the ratio of the Aid flow from UN agencies (US$) in 1969 in Middle East & North Africa (all income levels) to that in Middle income?
Your answer should be compact. 0.53. What is the ratio of the Aid flow from UN agencies (US$) of 1970 in Middle East & North Africa (all income levels) to that in Middle income?
Provide a succinct answer. 0.52. What is the ratio of the Aid flow from UN agencies (US$) of 1971 in Middle East & North Africa (all income levels) to that in Middle income?
Give a very brief answer. 0.39. What is the ratio of the Aid flow from UN agencies (US$) of 1972 in Middle East & North Africa (all income levels) to that in Middle income?
Ensure brevity in your answer.  0.39. What is the ratio of the Aid flow from UN agencies (US$) of 1969 in Middle East & North Africa (all income levels) to that in Other small states?
Provide a short and direct response. 34.65. What is the ratio of the Aid flow from UN agencies (US$) of 1970 in Middle East & North Africa (all income levels) to that in Other small states?
Your answer should be very brief. 8.64. What is the ratio of the Aid flow from UN agencies (US$) in 1971 in Middle East & North Africa (all income levels) to that in Other small states?
Provide a short and direct response. 5.85. What is the ratio of the Aid flow from UN agencies (US$) of 1972 in Middle East & North Africa (all income levels) to that in Other small states?
Your answer should be very brief. 6.71. What is the ratio of the Aid flow from UN agencies (US$) in 1969 in Middle East & North Africa (all income levels) to that in Small states?
Give a very brief answer. 18.03. What is the ratio of the Aid flow from UN agencies (US$) of 1970 in Middle East & North Africa (all income levels) to that in Small states?
Offer a very short reply. 7.86. What is the ratio of the Aid flow from UN agencies (US$) in 1971 in Middle East & North Africa (all income levels) to that in Small states?
Offer a very short reply. 5.35. What is the ratio of the Aid flow from UN agencies (US$) in 1972 in Middle East & North Africa (all income levels) to that in Small states?
Your answer should be very brief. 6.04. What is the ratio of the Aid flow from UN agencies (US$) of 1969 in Middle East & North Africa (all income levels) to that in South Asia?
Ensure brevity in your answer.  31.39. What is the ratio of the Aid flow from UN agencies (US$) in 1970 in Middle East & North Africa (all income levels) to that in South Asia?
Provide a short and direct response. 4.98. What is the ratio of the Aid flow from UN agencies (US$) of 1971 in Middle East & North Africa (all income levels) to that in South Asia?
Your answer should be very brief. 2.33. What is the ratio of the Aid flow from UN agencies (US$) in 1972 in Middle East & North Africa (all income levels) to that in South Asia?
Your answer should be very brief. 1.21. What is the ratio of the Aid flow from UN agencies (US$) of 1969 in Middle East & North Africa (developing only) to that in Middle income?
Offer a very short reply. 0.53. What is the ratio of the Aid flow from UN agencies (US$) in 1970 in Middle East & North Africa (developing only) to that in Middle income?
Make the answer very short. 0.51. What is the ratio of the Aid flow from UN agencies (US$) of 1971 in Middle East & North Africa (developing only) to that in Middle income?
Ensure brevity in your answer.  0.38. What is the ratio of the Aid flow from UN agencies (US$) of 1972 in Middle East & North Africa (developing only) to that in Middle income?
Your answer should be very brief. 0.4. What is the ratio of the Aid flow from UN agencies (US$) of 1969 in Middle East & North Africa (developing only) to that in Other small states?
Provide a short and direct response. 34.44. What is the ratio of the Aid flow from UN agencies (US$) of 1970 in Middle East & North Africa (developing only) to that in Other small states?
Offer a very short reply. 8.55. What is the ratio of the Aid flow from UN agencies (US$) of 1971 in Middle East & North Africa (developing only) to that in Other small states?
Provide a short and direct response. 5.79. What is the ratio of the Aid flow from UN agencies (US$) in 1972 in Middle East & North Africa (developing only) to that in Other small states?
Ensure brevity in your answer.  6.79. What is the ratio of the Aid flow from UN agencies (US$) of 1969 in Middle East & North Africa (developing only) to that in Small states?
Your response must be concise. 17.92. What is the ratio of the Aid flow from UN agencies (US$) of 1970 in Middle East & North Africa (developing only) to that in Small states?
Your response must be concise. 7.78. What is the ratio of the Aid flow from UN agencies (US$) in 1971 in Middle East & North Africa (developing only) to that in Small states?
Give a very brief answer. 5.3. What is the ratio of the Aid flow from UN agencies (US$) of 1972 in Middle East & North Africa (developing only) to that in Small states?
Keep it short and to the point. 6.11. What is the ratio of the Aid flow from UN agencies (US$) of 1969 in Middle East & North Africa (developing only) to that in South Asia?
Make the answer very short. 31.2. What is the ratio of the Aid flow from UN agencies (US$) in 1970 in Middle East & North Africa (developing only) to that in South Asia?
Ensure brevity in your answer.  4.93. What is the ratio of the Aid flow from UN agencies (US$) of 1971 in Middle East & North Africa (developing only) to that in South Asia?
Ensure brevity in your answer.  2.31. What is the ratio of the Aid flow from UN agencies (US$) in 1972 in Middle East & North Africa (developing only) to that in South Asia?
Your response must be concise. 1.22. What is the ratio of the Aid flow from UN agencies (US$) of 1969 in Middle income to that in Other small states?
Ensure brevity in your answer.  64.86. What is the ratio of the Aid flow from UN agencies (US$) of 1970 in Middle income to that in Other small states?
Offer a very short reply. 16.78. What is the ratio of the Aid flow from UN agencies (US$) of 1971 in Middle income to that in Other small states?
Your answer should be compact. 15.16. What is the ratio of the Aid flow from UN agencies (US$) of 1972 in Middle income to that in Other small states?
Keep it short and to the point. 17.19. What is the ratio of the Aid flow from UN agencies (US$) of 1969 in Middle income to that in Small states?
Your answer should be very brief. 33.74. What is the ratio of the Aid flow from UN agencies (US$) of 1970 in Middle income to that in Small states?
Provide a succinct answer. 15.26. What is the ratio of the Aid flow from UN agencies (US$) of 1971 in Middle income to that in Small states?
Offer a very short reply. 13.88. What is the ratio of the Aid flow from UN agencies (US$) in 1972 in Middle income to that in Small states?
Your answer should be very brief. 15.46. What is the ratio of the Aid flow from UN agencies (US$) of 1969 in Middle income to that in South Asia?
Your answer should be very brief. 58.75. What is the ratio of the Aid flow from UN agencies (US$) in 1970 in Middle income to that in South Asia?
Give a very brief answer. 9.67. What is the ratio of the Aid flow from UN agencies (US$) of 1971 in Middle income to that in South Asia?
Provide a succinct answer. 6.05. What is the ratio of the Aid flow from UN agencies (US$) of 1972 in Middle income to that in South Asia?
Make the answer very short. 3.09. What is the ratio of the Aid flow from UN agencies (US$) of 1969 in Other small states to that in Small states?
Provide a succinct answer. 0.52. What is the ratio of the Aid flow from UN agencies (US$) in 1970 in Other small states to that in Small states?
Your response must be concise. 0.91. What is the ratio of the Aid flow from UN agencies (US$) in 1971 in Other small states to that in Small states?
Your response must be concise. 0.92. What is the ratio of the Aid flow from UN agencies (US$) in 1972 in Other small states to that in Small states?
Provide a succinct answer. 0.9. What is the ratio of the Aid flow from UN agencies (US$) in 1969 in Other small states to that in South Asia?
Offer a very short reply. 0.91. What is the ratio of the Aid flow from UN agencies (US$) of 1970 in Other small states to that in South Asia?
Provide a short and direct response. 0.58. What is the ratio of the Aid flow from UN agencies (US$) in 1971 in Other small states to that in South Asia?
Your answer should be very brief. 0.4. What is the ratio of the Aid flow from UN agencies (US$) of 1972 in Other small states to that in South Asia?
Keep it short and to the point. 0.18. What is the ratio of the Aid flow from UN agencies (US$) of 1969 in Small states to that in South Asia?
Keep it short and to the point. 1.74. What is the ratio of the Aid flow from UN agencies (US$) in 1970 in Small states to that in South Asia?
Provide a short and direct response. 0.63. What is the ratio of the Aid flow from UN agencies (US$) of 1971 in Small states to that in South Asia?
Give a very brief answer. 0.44. What is the ratio of the Aid flow from UN agencies (US$) of 1972 in Small states to that in South Asia?
Make the answer very short. 0.2. What is the difference between the highest and the second highest Aid flow from UN agencies (US$) of 1969?
Your response must be concise. 2.33e+07. What is the difference between the highest and the second highest Aid flow from UN agencies (US$) in 1970?
Give a very brief answer. 4.50e+07. What is the difference between the highest and the second highest Aid flow from UN agencies (US$) of 1971?
Make the answer very short. 7.48e+07. What is the difference between the highest and the second highest Aid flow from UN agencies (US$) of 1972?
Offer a very short reply. 5.69e+07. What is the difference between the highest and the lowest Aid flow from UN agencies (US$) of 1969?
Offer a very short reply. 4.92e+07. What is the difference between the highest and the lowest Aid flow from UN agencies (US$) of 1970?
Ensure brevity in your answer.  8.73e+07. What is the difference between the highest and the lowest Aid flow from UN agencies (US$) in 1971?
Keep it short and to the point. 1.14e+08. What is the difference between the highest and the lowest Aid flow from UN agencies (US$) in 1972?
Provide a short and direct response. 8.86e+07. 